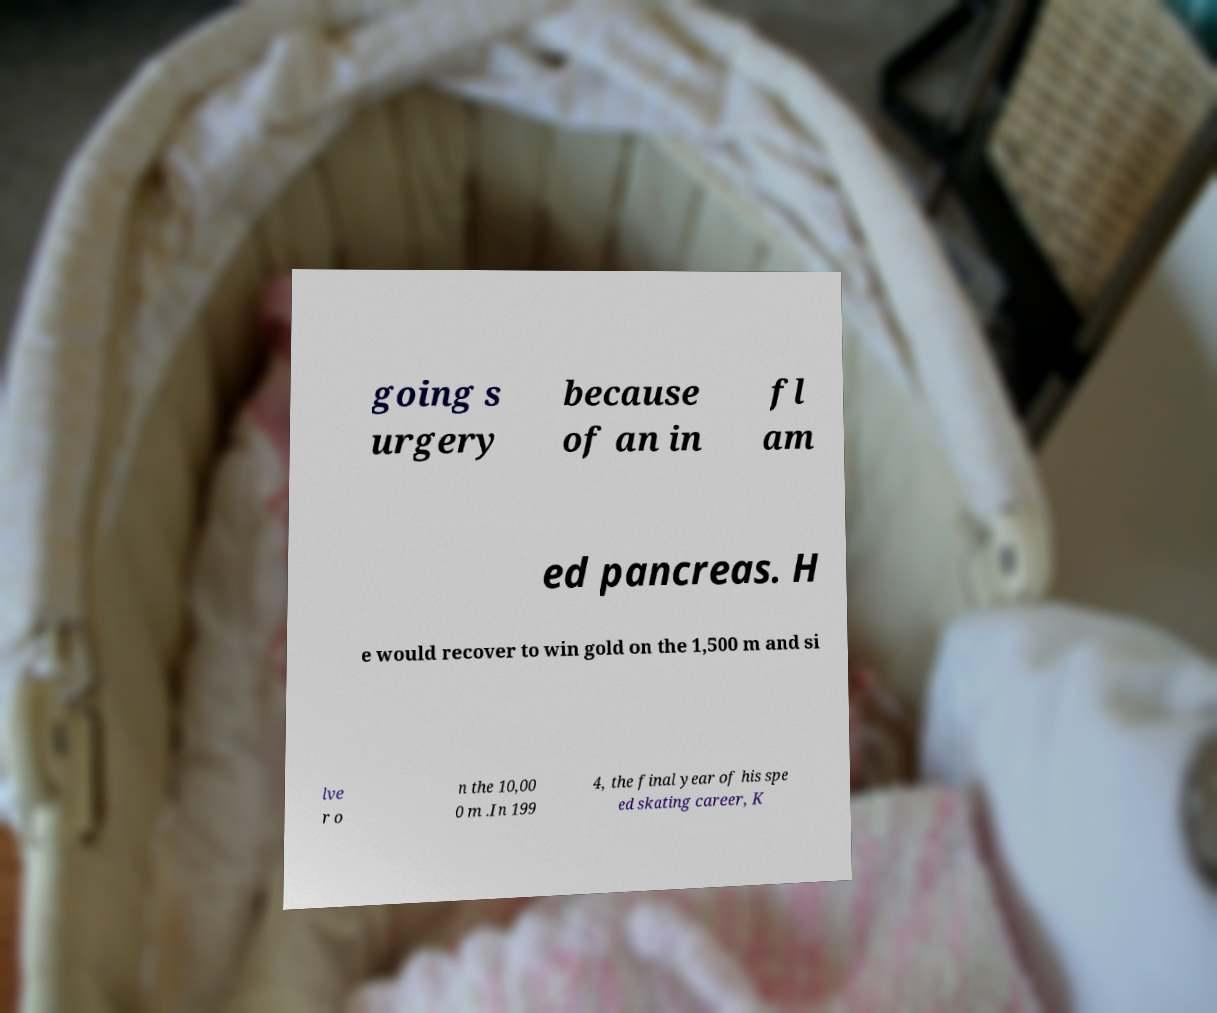For documentation purposes, I need the text within this image transcribed. Could you provide that? going s urgery because of an in fl am ed pancreas. H e would recover to win gold on the 1,500 m and si lve r o n the 10,00 0 m .In 199 4, the final year of his spe ed skating career, K 